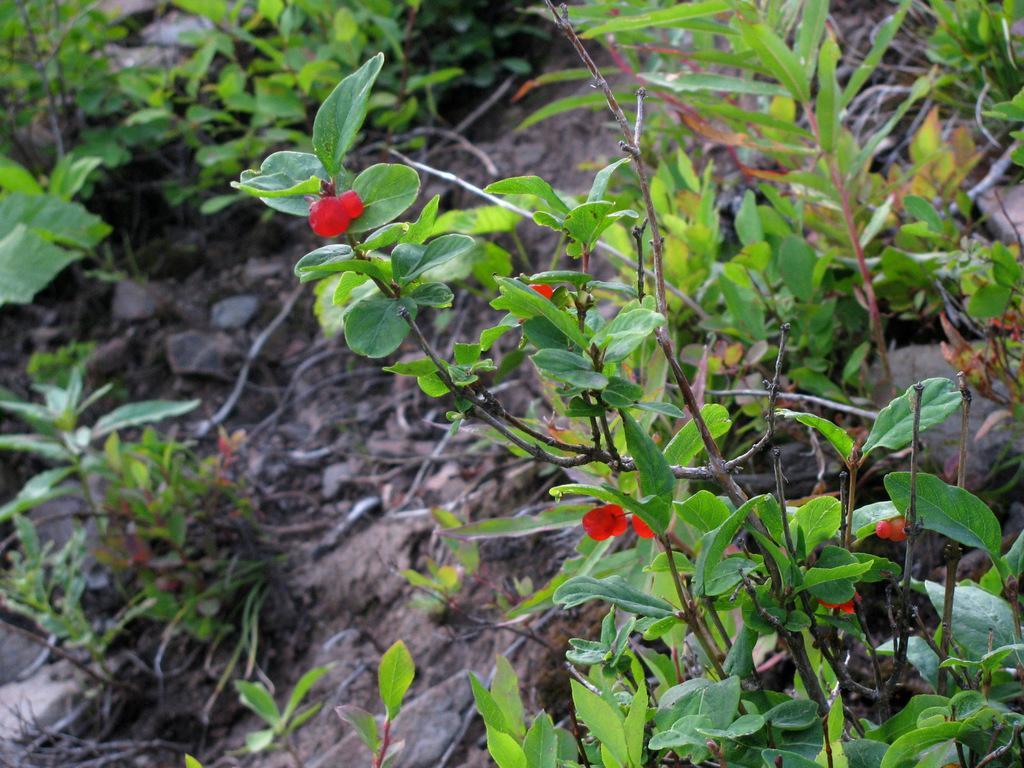Could you give a brief overview of what you see in this image? In this image we can see there are flowers and plants on the surface. 